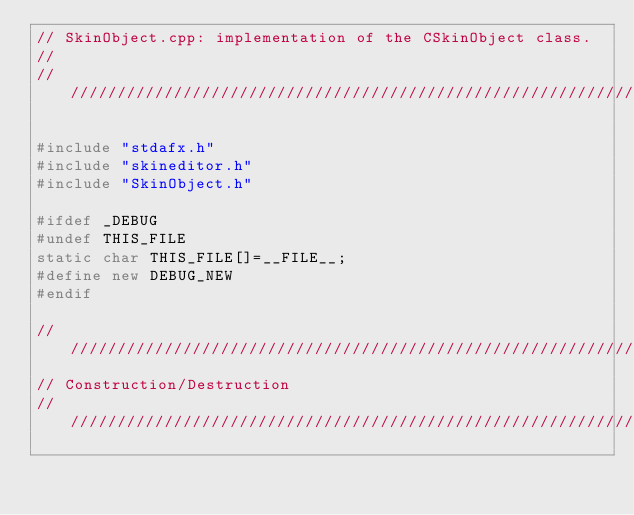<code> <loc_0><loc_0><loc_500><loc_500><_C++_>// SkinObject.cpp: implementation of the CSkinObject class.
//
//////////////////////////////////////////////////////////////////////

#include "stdafx.h"
#include "skineditor.h"
#include "SkinObject.h"

#ifdef _DEBUG
#undef THIS_FILE
static char THIS_FILE[]=__FILE__;
#define new DEBUG_NEW
#endif

//////////////////////////////////////////////////////////////////////
// Construction/Destruction
//////////////////////////////////////////////////////////////////////
</code> 